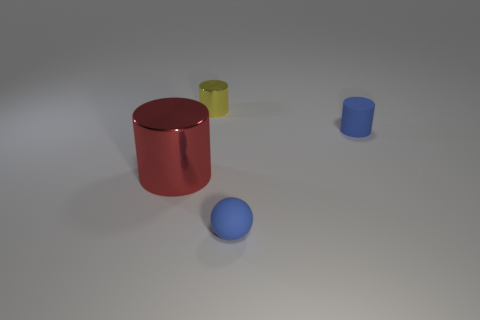Subtract all metal cylinders. How many cylinders are left? 1 Subtract all yellow cylinders. How many cylinders are left? 2 Add 2 tiny red spheres. How many objects exist? 6 Subtract 3 cylinders. How many cylinders are left? 0 Subtract all balls. How many objects are left? 3 Subtract all cyan spheres. Subtract all red blocks. How many spheres are left? 1 Subtract all purple spheres. How many cyan cylinders are left? 0 Subtract all red cylinders. Subtract all small red metal things. How many objects are left? 3 Add 3 tiny blue things. How many tiny blue things are left? 5 Add 3 blue things. How many blue things exist? 5 